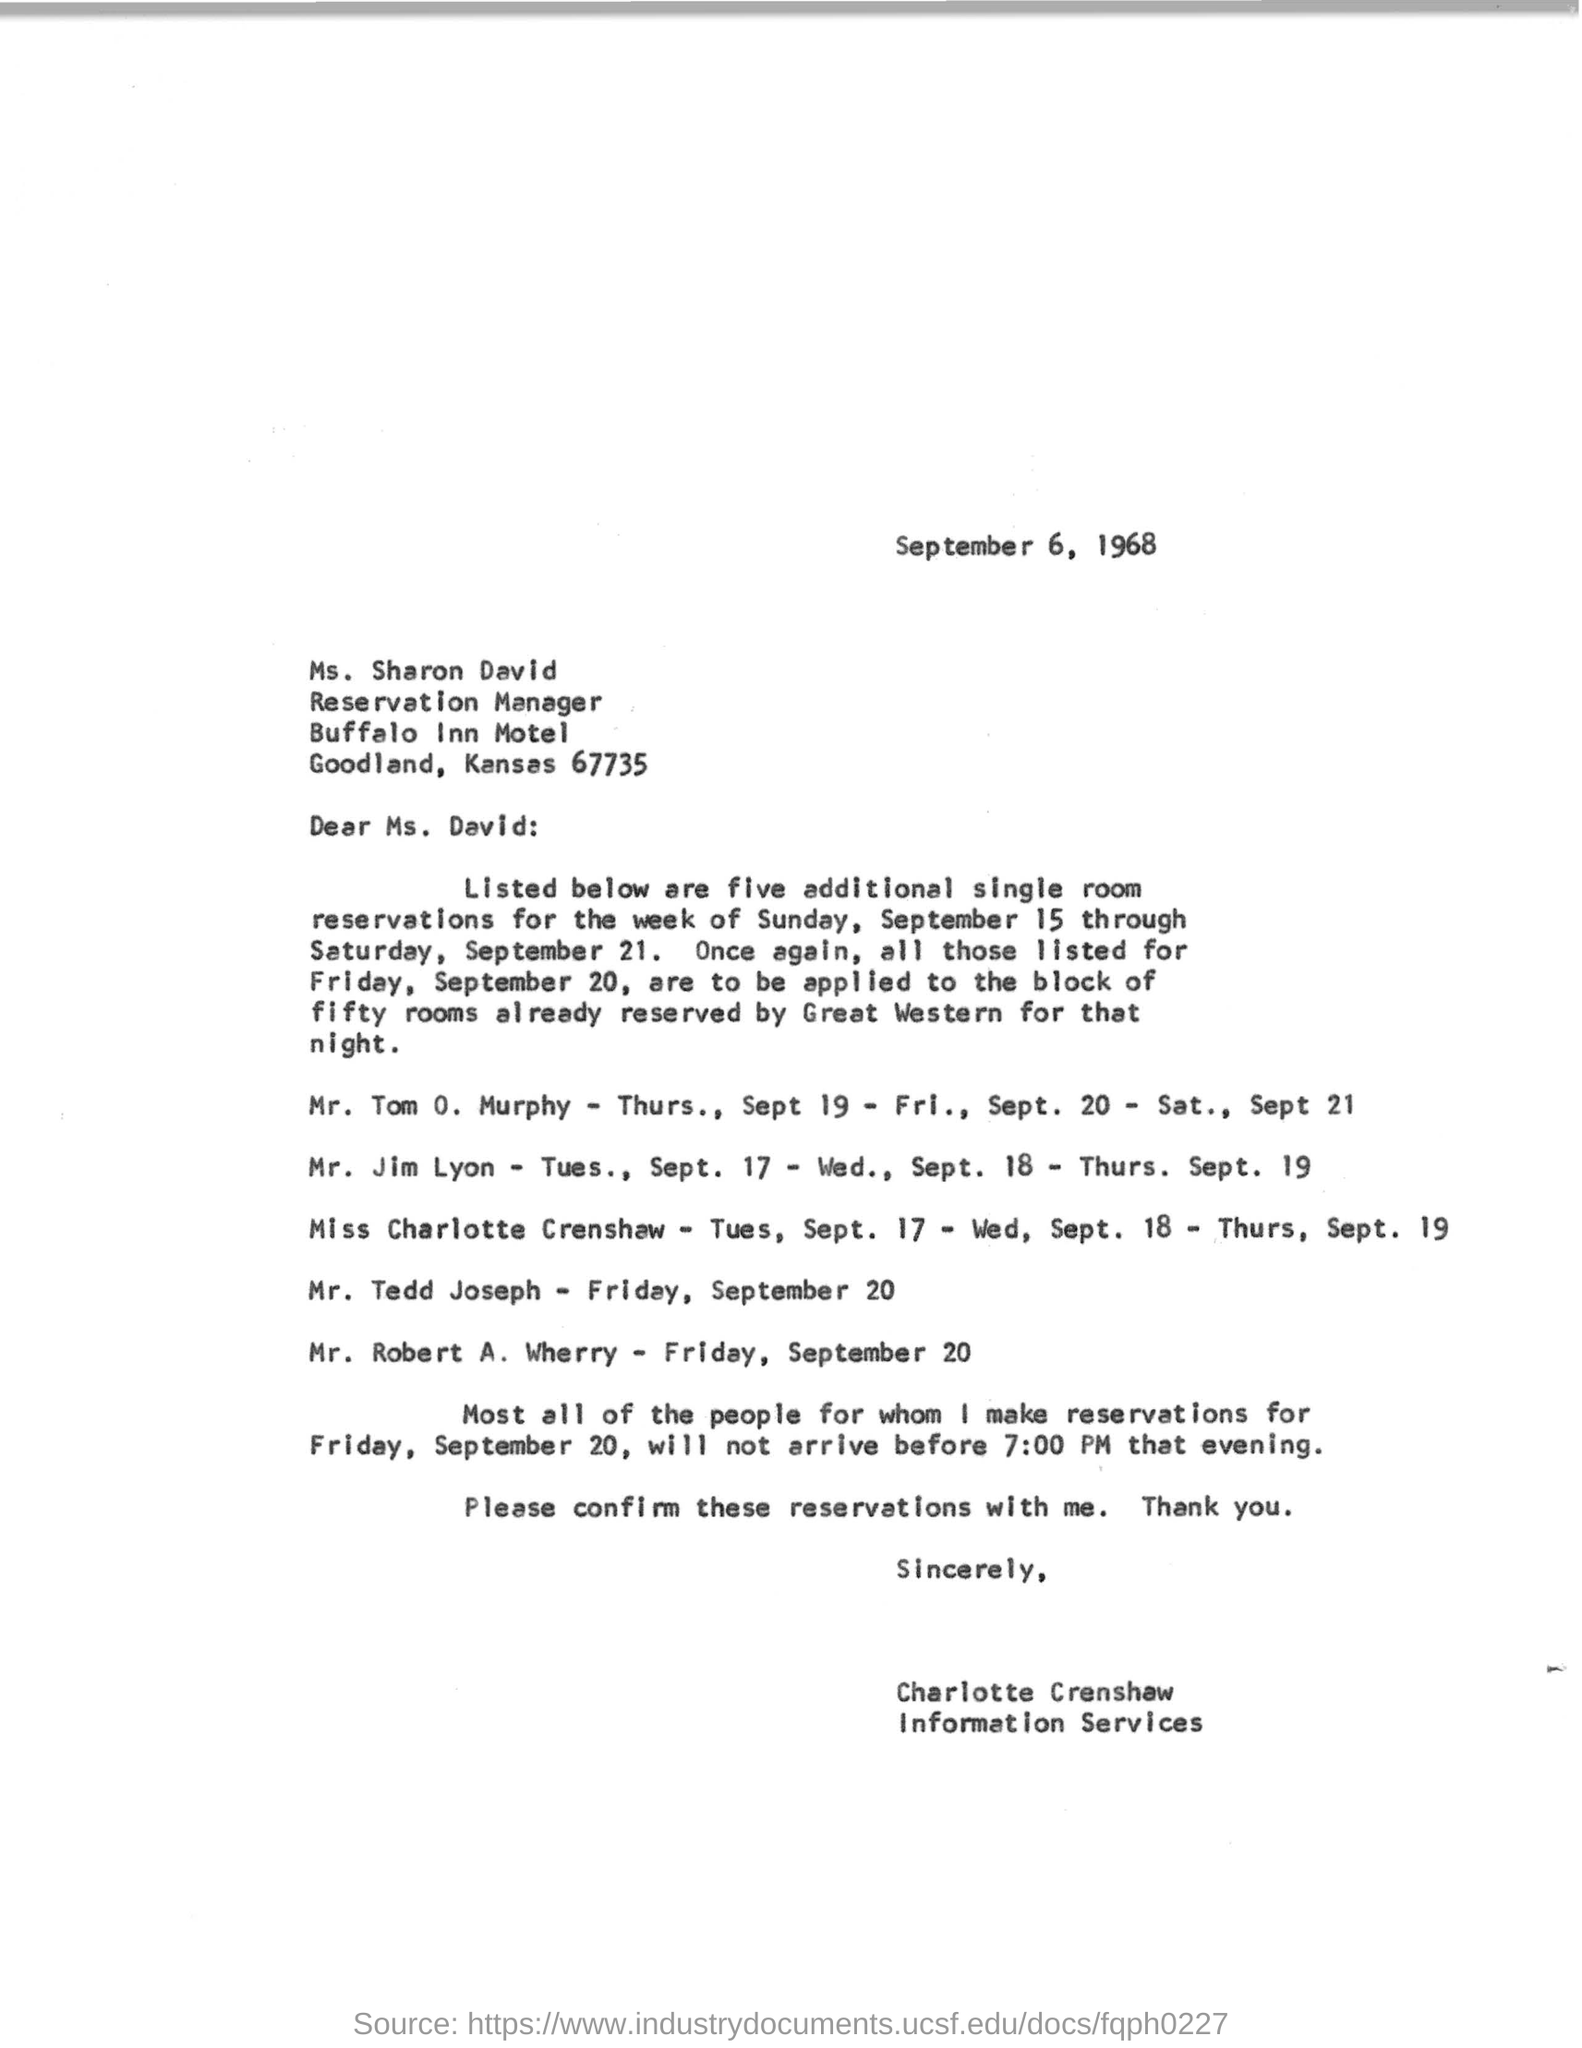When is the letter dated on ?
Keep it short and to the point. September 6, 1968. Who is the reservation manager?
Offer a terse response. Ms. Sharon David. What is location of buffalo inn motel?
Your answer should be compact. Goodland, kansas 67735. On which day single room was reserved for mr. tedd joseph ?
Your answer should be compact. Friday, September 20. 